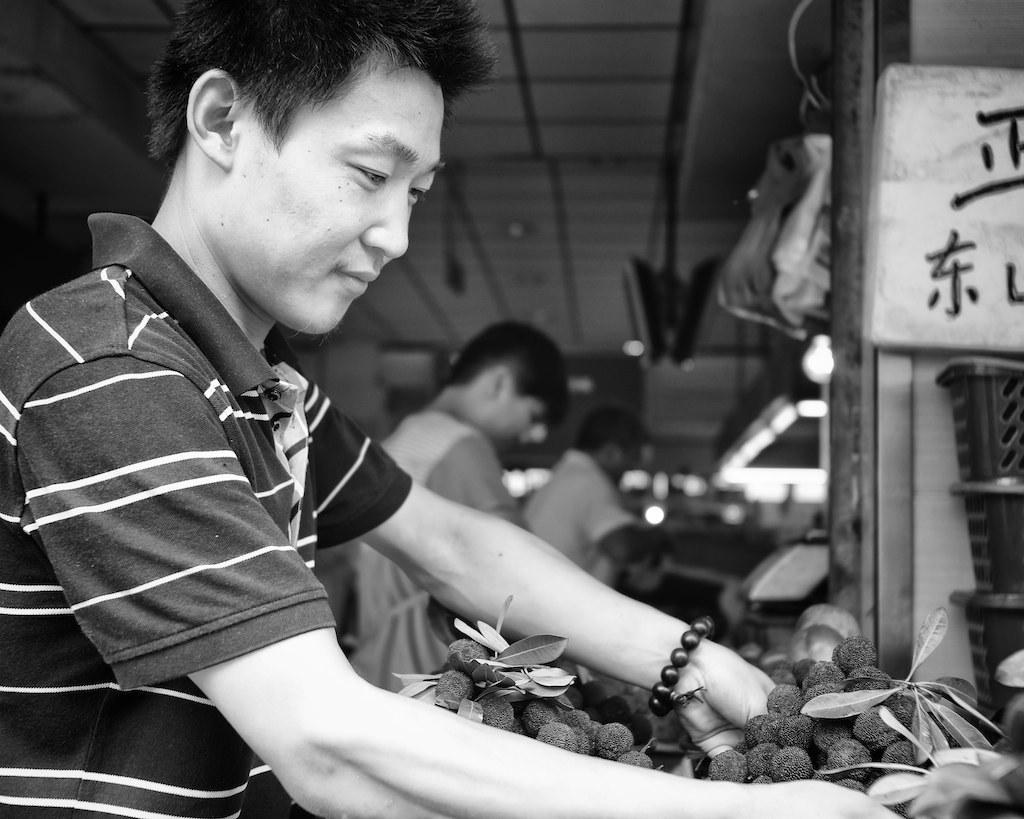What is the position of the person in the image? There is a person standing in the left corner of the image. What is in front of the person? There are objects in front of the person. How many other persons are visible in the image? There are two other persons in the background of the image. What type of wood is used to build the respect in the image? There is no mention of respect or wood in the image, so this question cannot be answered. 